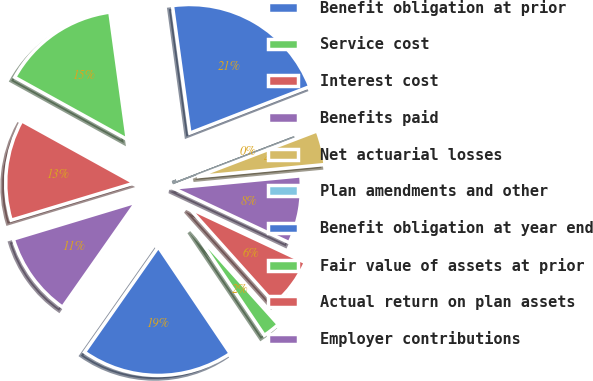Convert chart to OTSL. <chart><loc_0><loc_0><loc_500><loc_500><pie_chart><fcel>Benefit obligation at prior<fcel>Service cost<fcel>Interest cost<fcel>Benefits paid<fcel>Net actuarial losses<fcel>Plan amendments and other<fcel>Benefit obligation at year end<fcel>Fair value of assets at prior<fcel>Actual return on plan assets<fcel>Employer contributions<nl><fcel>19.17%<fcel>2.19%<fcel>6.39%<fcel>8.49%<fcel>4.29%<fcel>0.09%<fcel>21.27%<fcel>14.8%<fcel>12.7%<fcel>10.6%<nl></chart> 